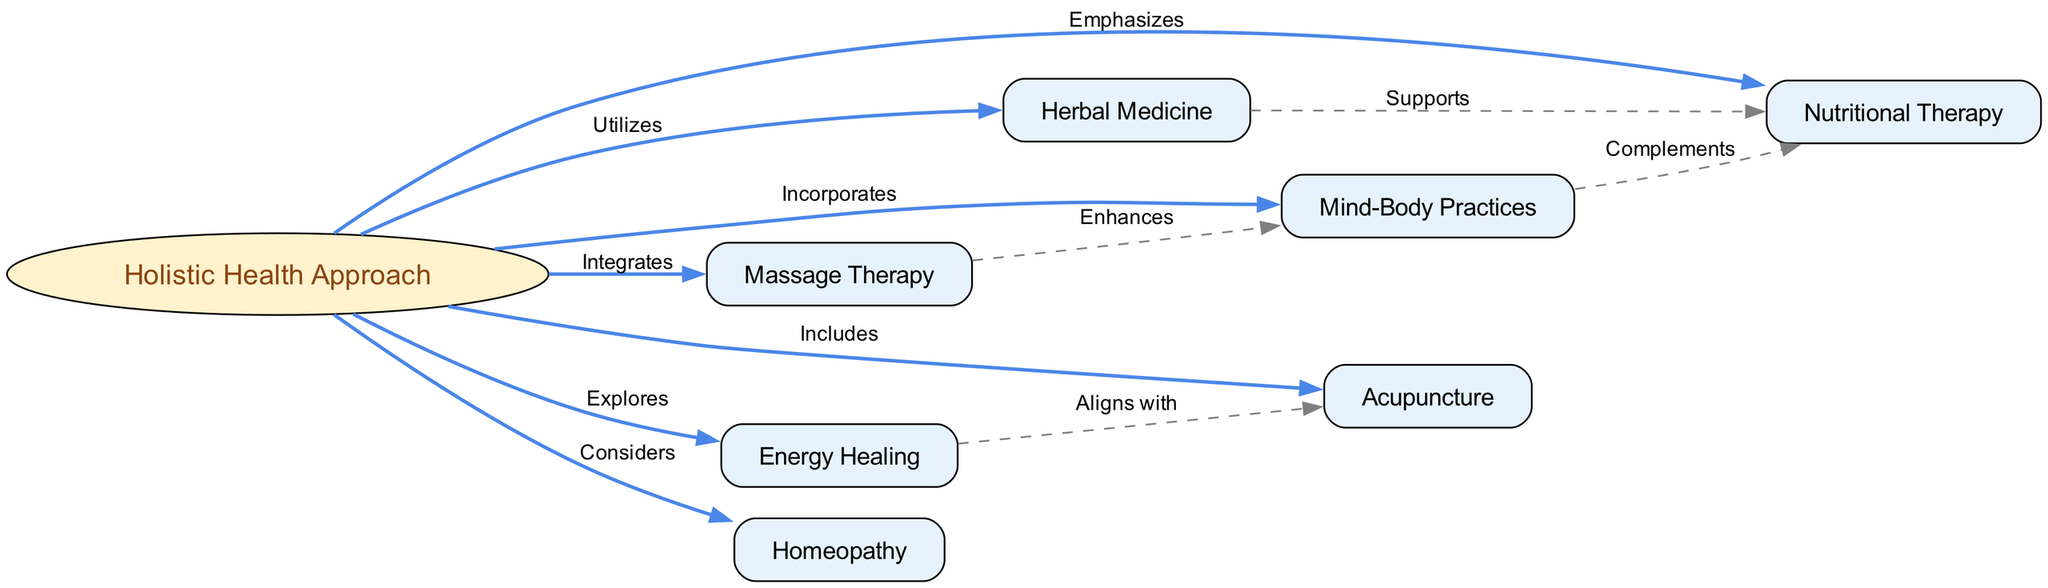What is the central node of the diagram? The diagram's central node is labeled "Holistic Health Approach." It serves as the main concept from which various other approaches emanate.
Answer: Holistic Health Approach How many nodes are present in the diagram? By counting the nodes listed in the data, there are 8 nodes in total associated with this holistic health framework.
Answer: 8 What type of practices does the "Holistic Health Approach" incorporate? The "Holistic Health Approach" incorporates "Mind-Body Practices" as one of its primary components, reflecting a focus on the connection between mental and physical health.
Answer: Mind-Body Practices Which approach supports Nutritional Therapy? The approach that supports "Nutritional Therapy" is "Herbal Medicine," as indicated by the direct connection showing its supportive role in nutrition.
Answer: Herbal Medicine What is the relationship between "Massage Therapy" and "Mind-Body Practices"? "Massage Therapy" enhances "Mind-Body Practices," meaning it provides additional benefits or improvements to mental and physical health methods.
Answer: Enhances Which two approaches align with each other according to the diagram? "Energy Healing" and "Acupuncture" align with each other, suggesting that they share synergies or common goals in their practices.
Answer: Aligns with What does "Nutrition" complement according to the diagram? "Nutrition" complements "Mind-Body Practices," indicating that optimal nutrition is seen as beneficial to mental and physical wellness techniques.
Answer: Mind-Body Practices How many edges are there connecting "Holistic Health Approach" to other nodes? There are 7 edges directly connecting the "Holistic Health Approach" to other nodes in the diagram, describing various relationships.
Answer: 7 What approach does "Acupuncture" belong to in the context of holistic health? "Acupuncture" is included in the "Holistic Health Approach," showcasing its relevance as a therapeutic method within this framework.
Answer: Included Which therapy integrates with "Massage Therapy"? "Holistic Health Approach" integrates with "Massage Therapy," indicating that it is considered an essential part of the overall health strategy.
Answer: Integrates 